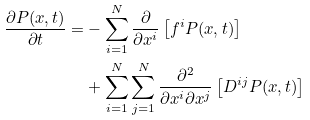<formula> <loc_0><loc_0><loc_500><loc_500>\frac { \partial P ( x , t ) } { \partial t } = & - \sum _ { i = 1 } ^ { N } \frac { \partial } { \partial x ^ { i } } \left [ f ^ { i } P ( x , t ) \right ] \\ & + \sum _ { i = 1 } ^ { N } \sum _ { j = 1 } ^ { N } \frac { \partial ^ { 2 } } { \partial x ^ { i } \partial x ^ { j } } \left [ D ^ { i j } P ( x , t ) \right ]</formula> 